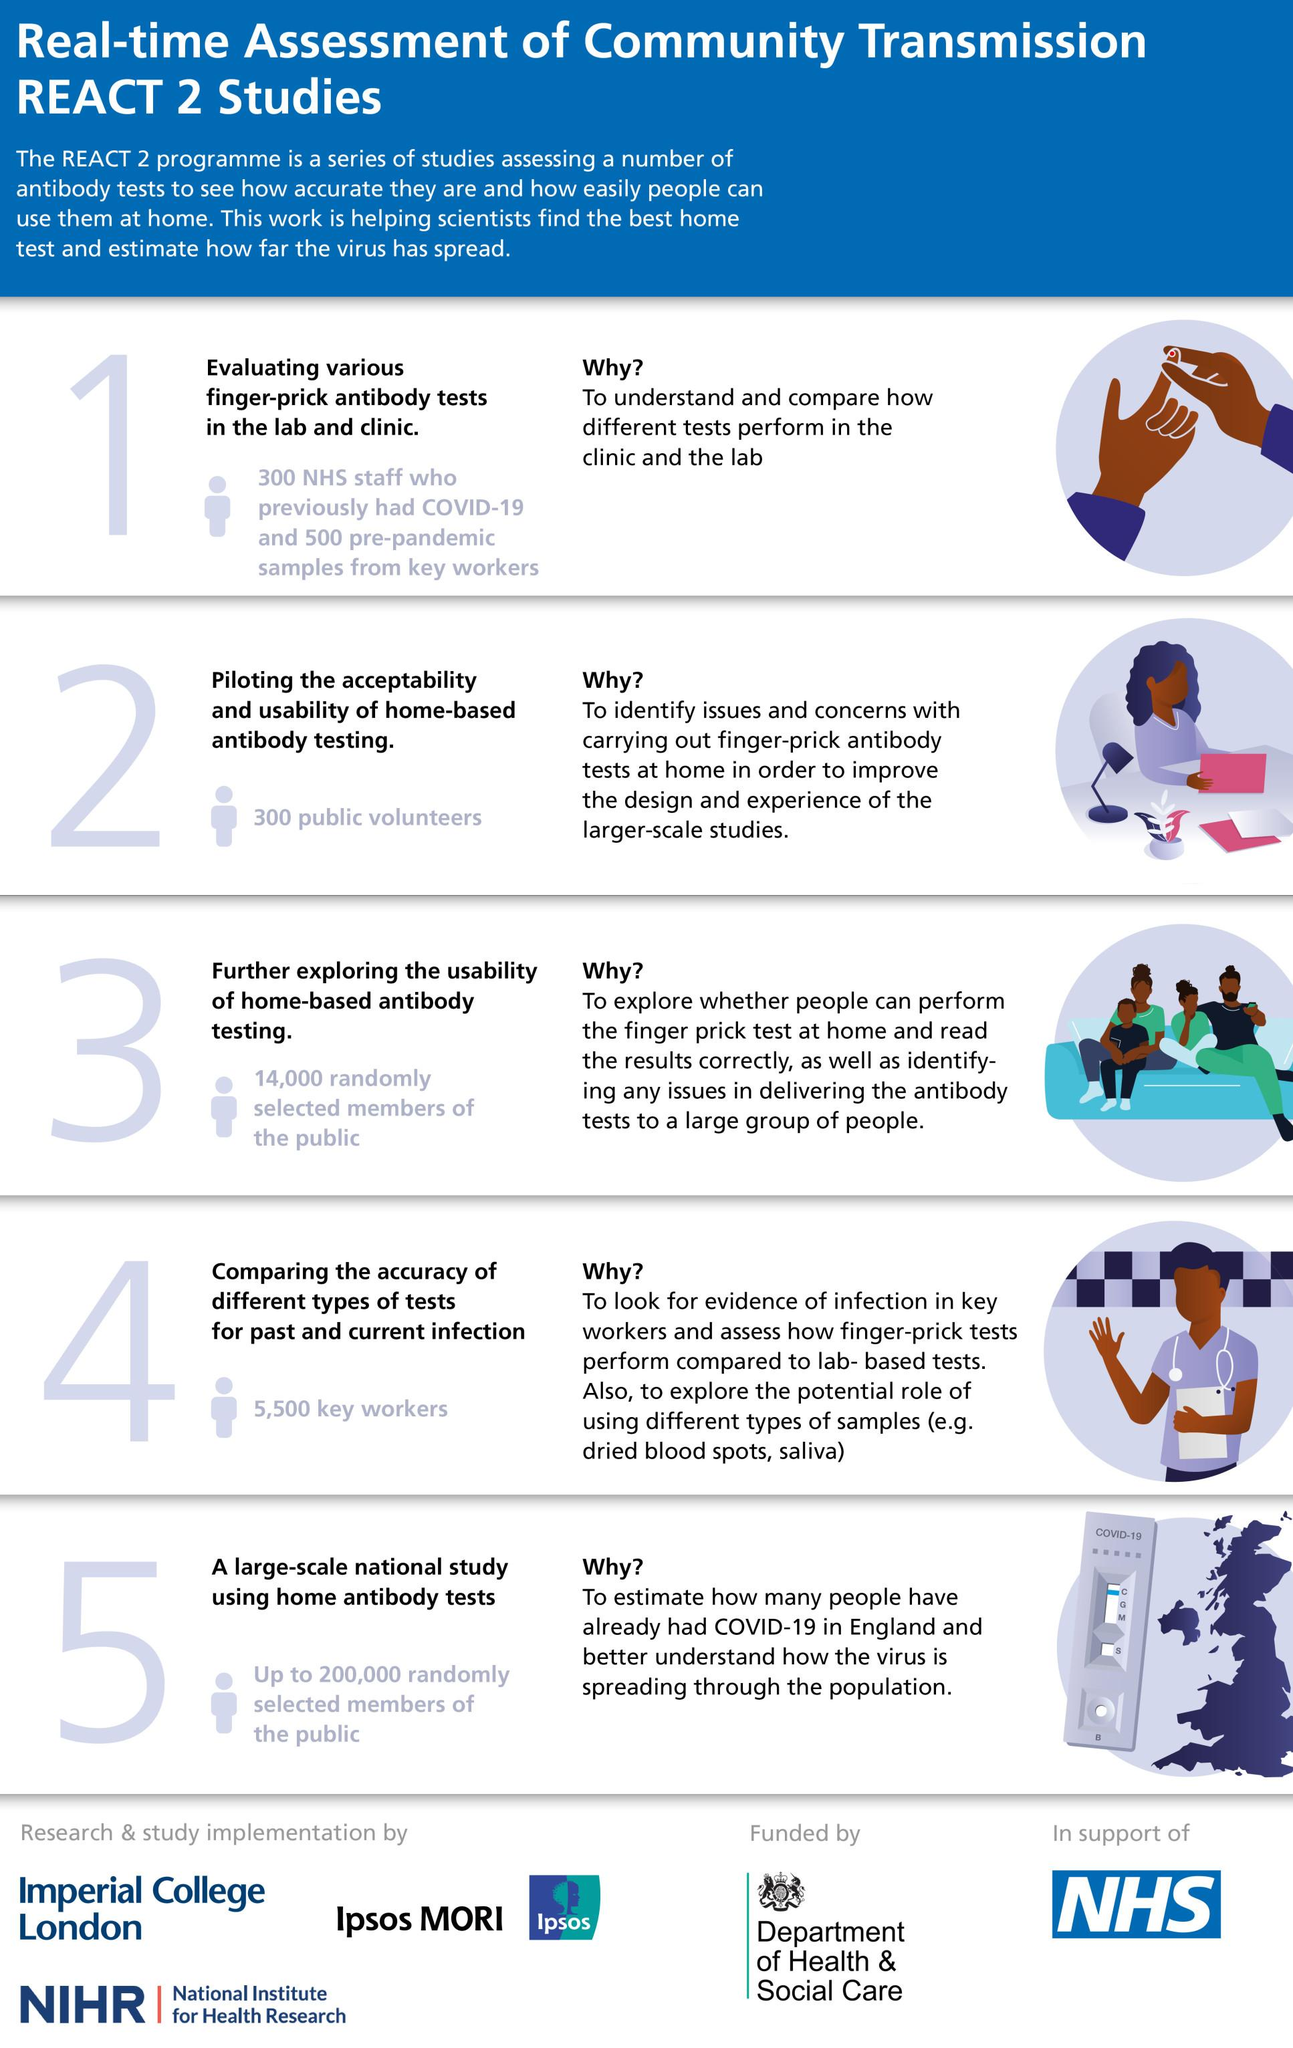Highlight a few significant elements in this photo. A randomly selected sample of 18,600 members of the public was used in step 5, and compared to the sample of 30,000 members of the public in step 3. A total of 300 public volunteers were enlisted to evaluate the acceptability and usability of home-based antibody testing. A total of 14,000 members of the general public were randomly selected to participate in the study that aimed to further explore the usability of home-based antibody testing. 